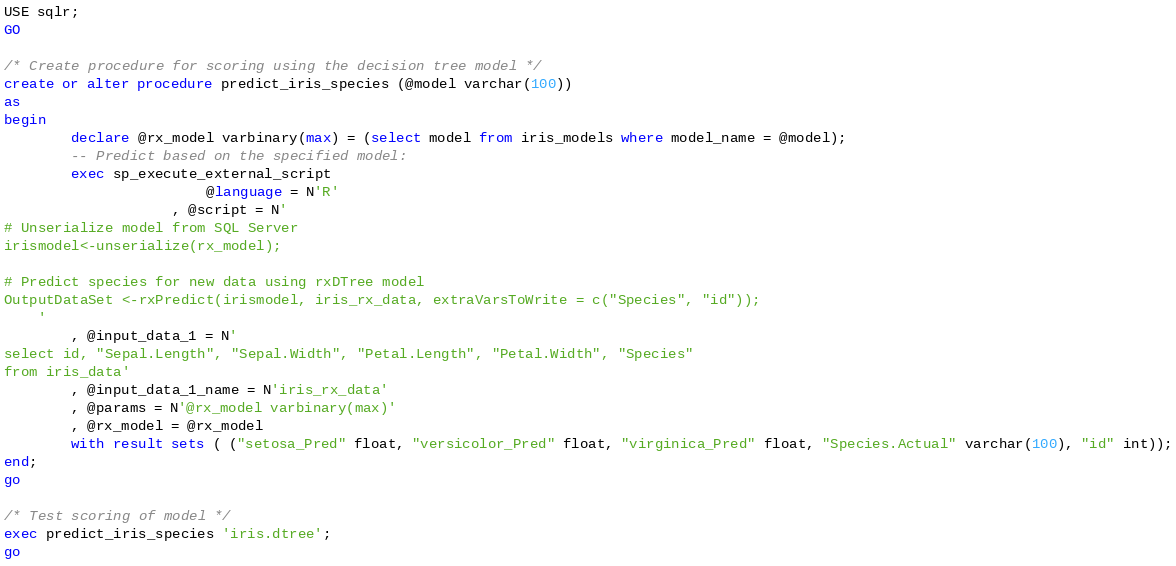<code> <loc_0><loc_0><loc_500><loc_500><_SQL_>USE sqlr;
GO

/* Create procedure for scoring using the decision tree model */
create or alter procedure predict_iris_species (@model varchar(100))
as
begin
		declare @rx_model varbinary(max) = (select model from iris_models where model_name = @model);
		-- Predict based on the specified model:
		exec sp_execute_external_script 
						@language = N'R'
					, @script = N'
# Unserialize model from SQL Server
irismodel<-unserialize(rx_model);

# Predict species for new data using rxDTree model
OutputDataSet <-rxPredict(irismodel, iris_rx_data, extraVarsToWrite = c("Species", "id"));
	'
		, @input_data_1 = N'
select id, "Sepal.Length", "Sepal.Width", "Petal.Length", "Petal.Width", "Species"
from iris_data'
		, @input_data_1_name = N'iris_rx_data'
		, @params = N'@rx_model varbinary(max)'
		, @rx_model = @rx_model
		with result sets ( ("setosa_Pred" float, "versicolor_Pred" float, "virginica_Pred" float, "Species.Actual" varchar(100), "id" int));
end;
go

/* Test scoring of model */
exec predict_iris_species 'iris.dtree';
go
</code> 